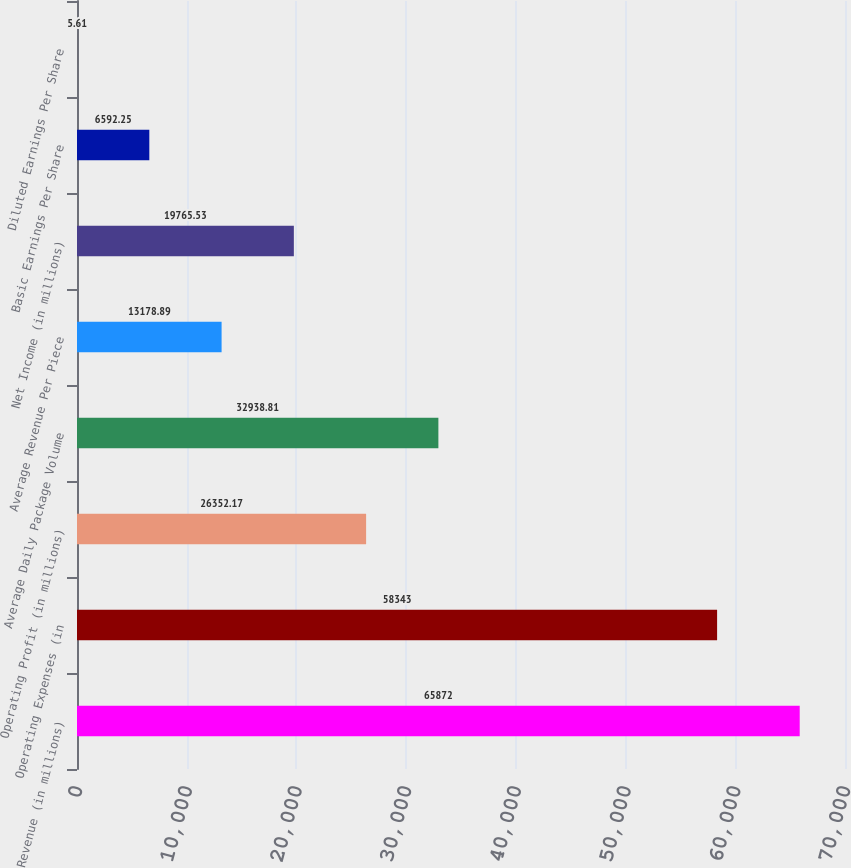Convert chart. <chart><loc_0><loc_0><loc_500><loc_500><bar_chart><fcel>Revenue (in millions)<fcel>Operating Expenses (in<fcel>Operating Profit (in millions)<fcel>Average Daily Package Volume<fcel>Average Revenue Per Piece<fcel>Net Income (in millions)<fcel>Basic Earnings Per Share<fcel>Diluted Earnings Per Share<nl><fcel>65872<fcel>58343<fcel>26352.2<fcel>32938.8<fcel>13178.9<fcel>19765.5<fcel>6592.25<fcel>5.61<nl></chart> 